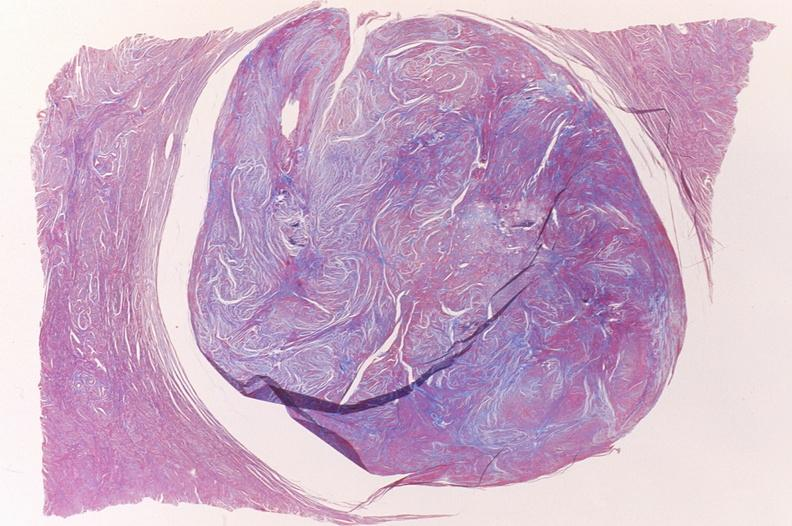does eosinophilic adenoma show leiomyoma, trichrome?
Answer the question using a single word or phrase. No 